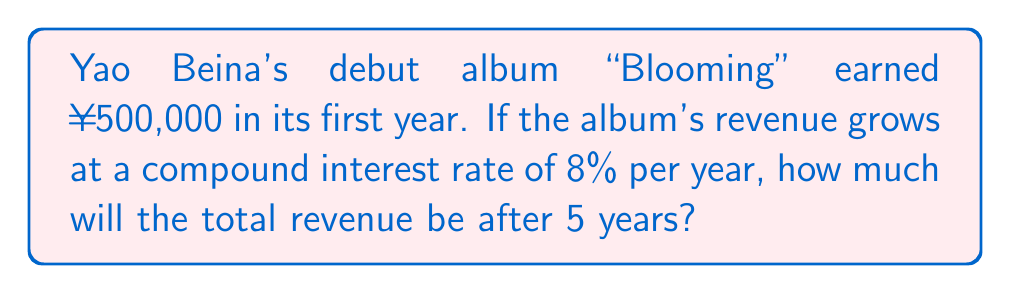Help me with this question. Let's approach this step-by-step using the compound interest formula:

1. The compound interest formula is:
   $$A = P(1 + r)^n$$
   Where:
   $A$ = Final amount
   $P$ = Principal (initial investment)
   $r$ = Annual interest rate (in decimal form)
   $n$ = Number of years

2. We know:
   $P = ¥500,000$
   $r = 8\% = 0.08$
   $n = 5$ years

3. Let's substitute these values into the formula:
   $$A = 500,000(1 + 0.08)^5$$

4. Calculate the value inside the parentheses:
   $$A = 500,000(1.08)^5$$

5. Now, calculate $(1.08)^5$:
   $$(1.08)^5 = 1.469328$$

6. Multiply this by the initial amount:
   $$A = 500,000 \times 1.469328 = 734,664$$

Therefore, after 5 years, the total revenue will be ¥734,664.
Answer: ¥734,664 